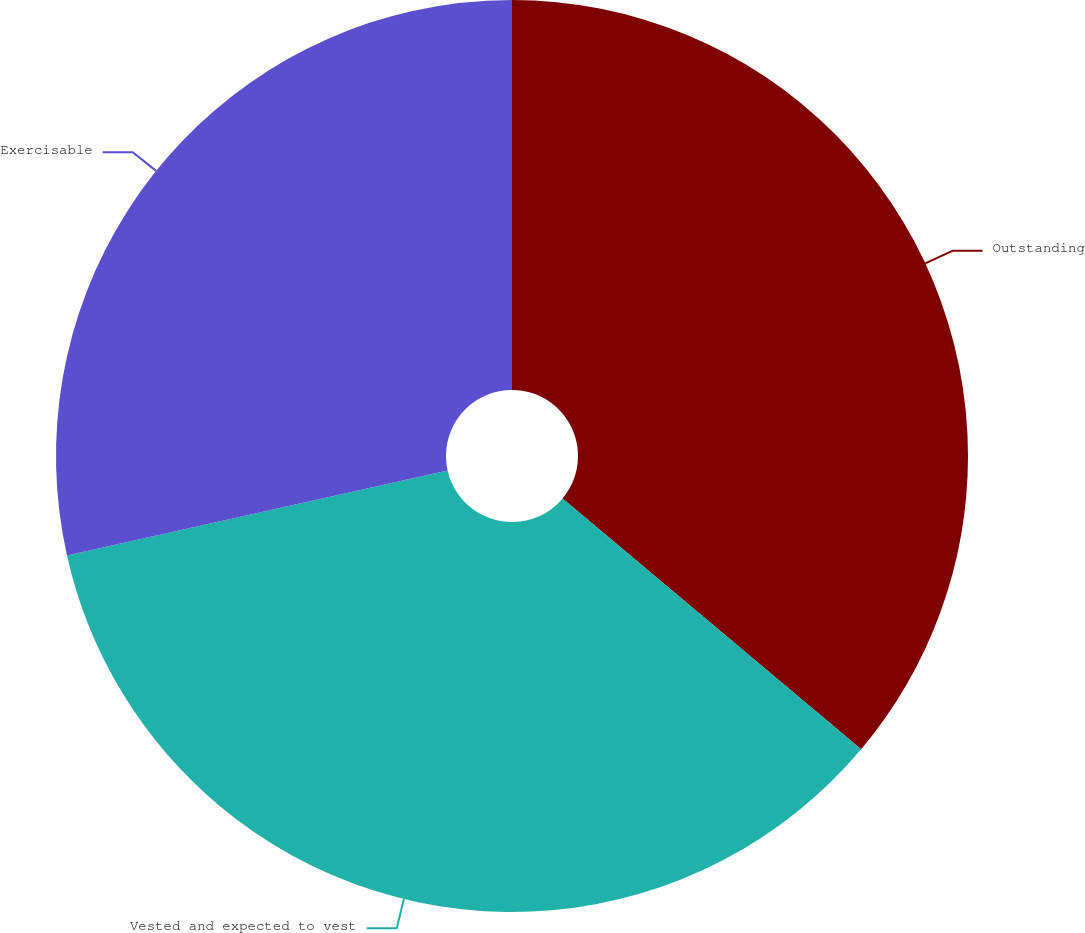Convert chart to OTSL. <chart><loc_0><loc_0><loc_500><loc_500><pie_chart><fcel>Outstanding<fcel>Vested and expected to vest<fcel>Exercisable<nl><fcel>36.12%<fcel>35.38%<fcel>28.5%<nl></chart> 